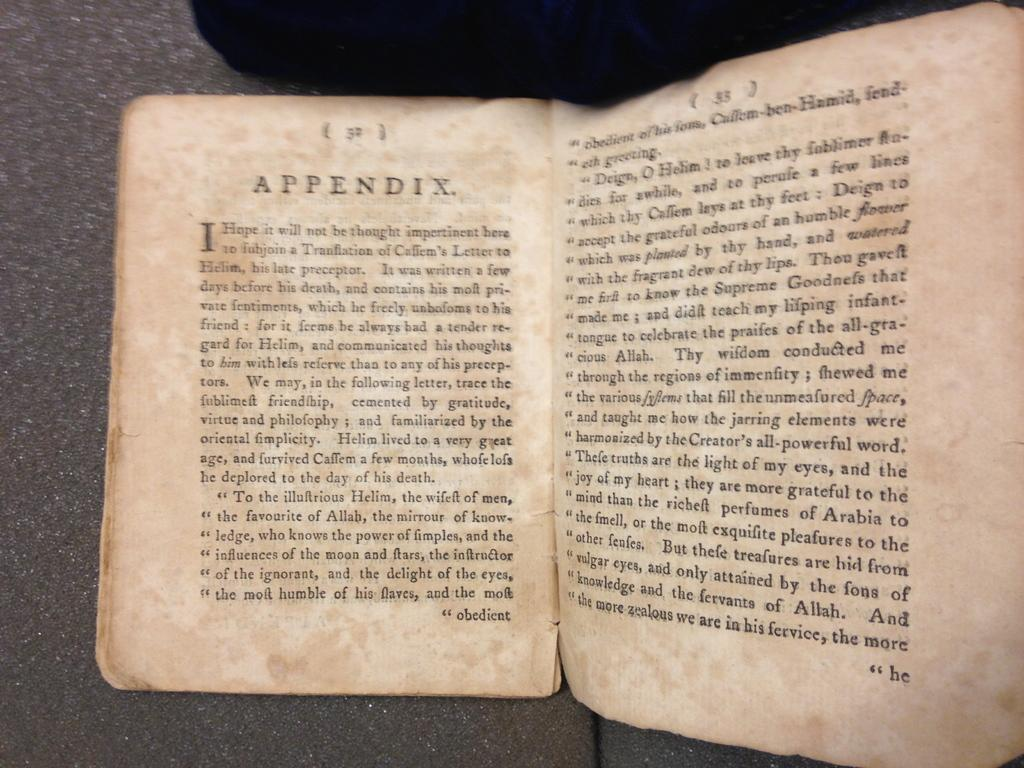Provide a one-sentence caption for the provided image. The book is open to the beginning of the Appendix section. 